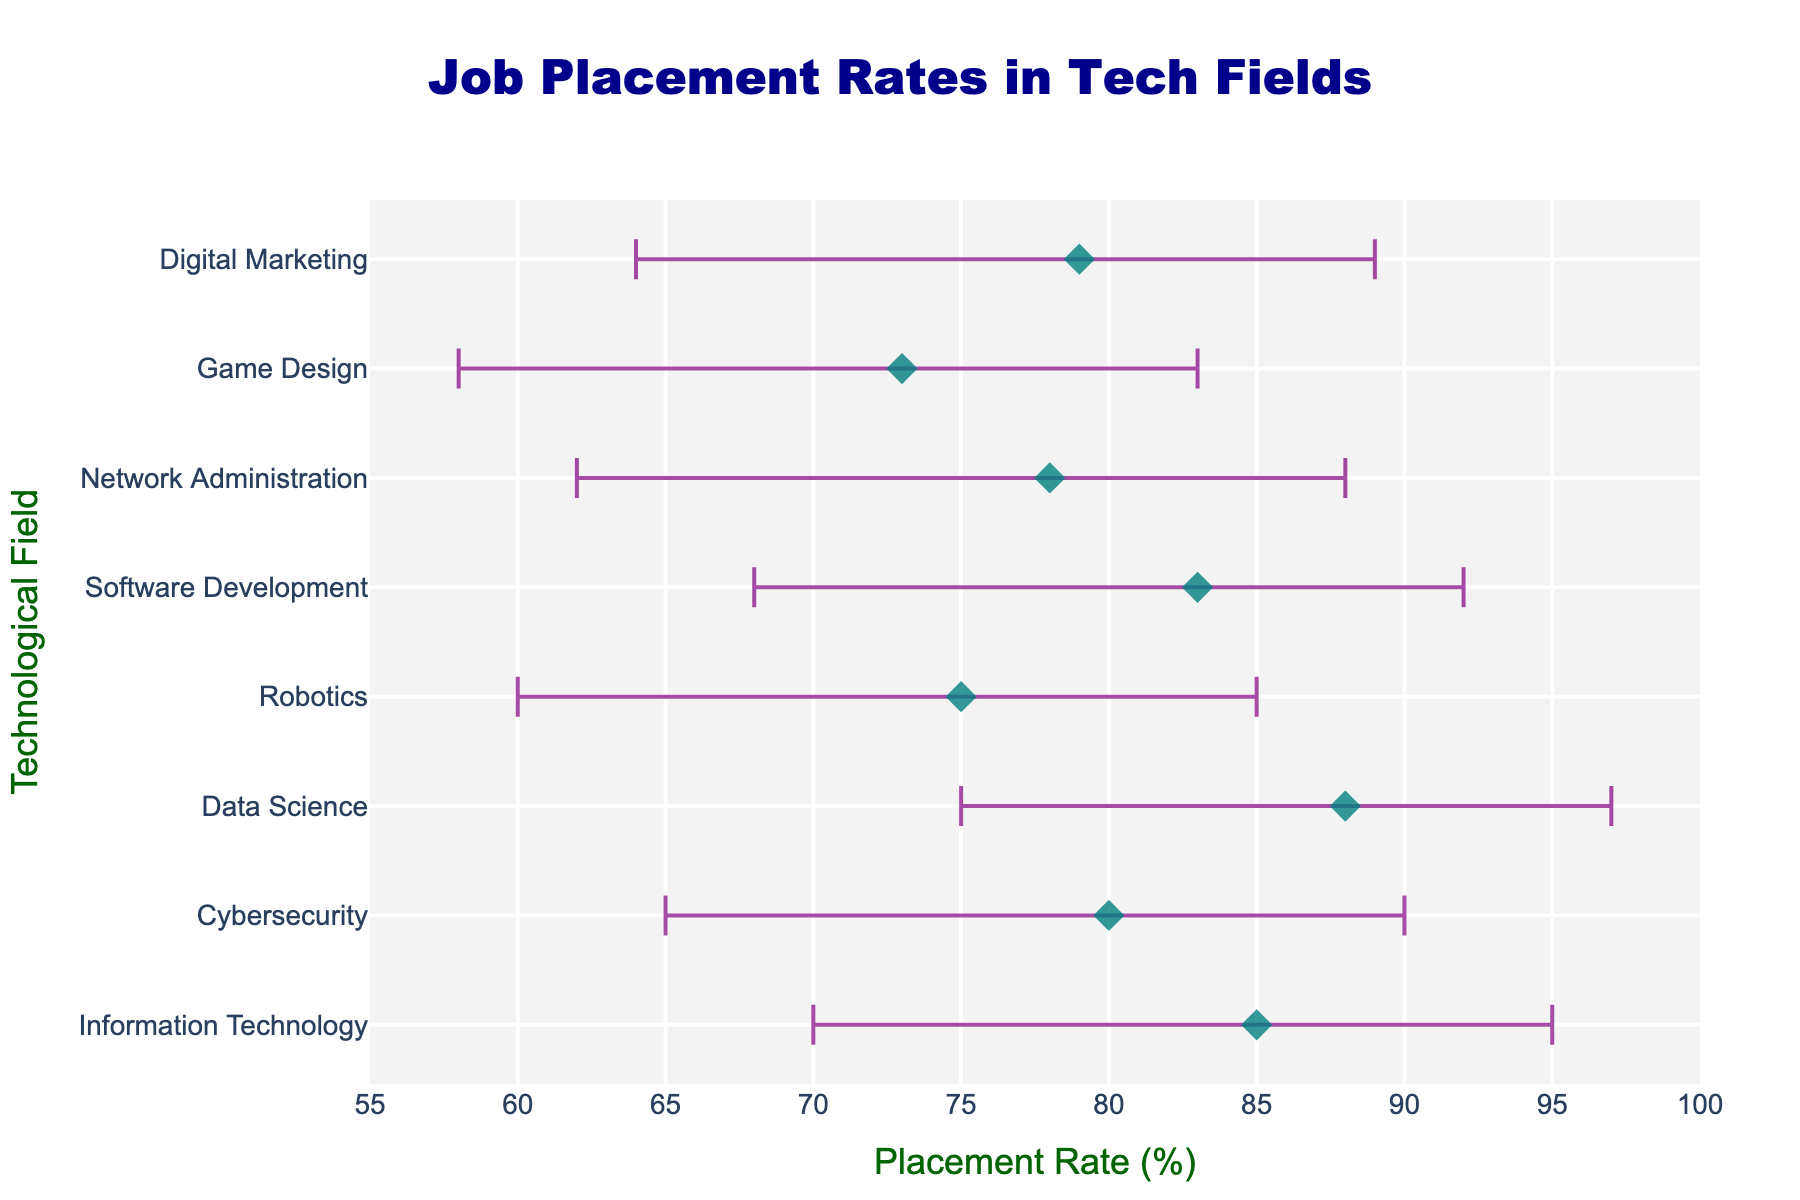What's the title of the figure? The title is positioned at the top center of the figure.
Answer: Job Placement Rates in Tech Fields Which technological field has the highest mean job placement rate? We look at the mean job placement rates and find the one with the highest value.
Answer: Data Science What is the range (difference between maximum and minimum) of placement rates for Cybersecurity? The range is calculated as the difference between the maximum and minimum placement rates. For Cybersecurity, it is 90 - 65.
Answer: 25 How does the mean placement rate for Information Technology compare to that of Software Development? Look at the mean placement rates for both fields and compare them. Information Technology has a mean placement rate of 85%, and Software Development has a mean placement rate of 83%.
Answer: Information Technology is higher What is the average maximum placement rate across all technological fields? Add the maximum placement rates for all fields and divide by the number of fields. \( (95 + 90 + 97 + 85 + 92 + 88 + 83 + 89) / 8 \)
Answer: 89.875 Which field shows the widest spread in placement rates? The spread can be considered as the difference between the maximum and minimum placement rates. Robotics has the largest spread, calculated as 85 - 60.
Answer: Robotics What color and shape are used for the data points? Observing the visual representation, the data points are colored teal (dark green-blue) and shaped like diamonds.
Answer: Teal diamonds In which field is the lower error bar (difference between mean and minimum rates) the largest? Calculate the difference between the mean and minimum rates for each field and identify the largest value. For Robotics, it's the largest as 75 - 60 = 15.
Answer: Robotics How does the average mean placement rate of all fields compare to the mean placement rate of Data Science? Calculate the average mean placement rate: \( (85 + 80 + 88 + 75 + 83 + 78 + 73 + 79) / 8 \), and compare it to Data Science's mean, which is 88.
Answer: Average of all fields is 80.125, so Data Science is higher What is the placement rate standard deviation for Digital Marketing? Look at the standard deviation value for Digital Marketing from the provided data.
Answer: 6 